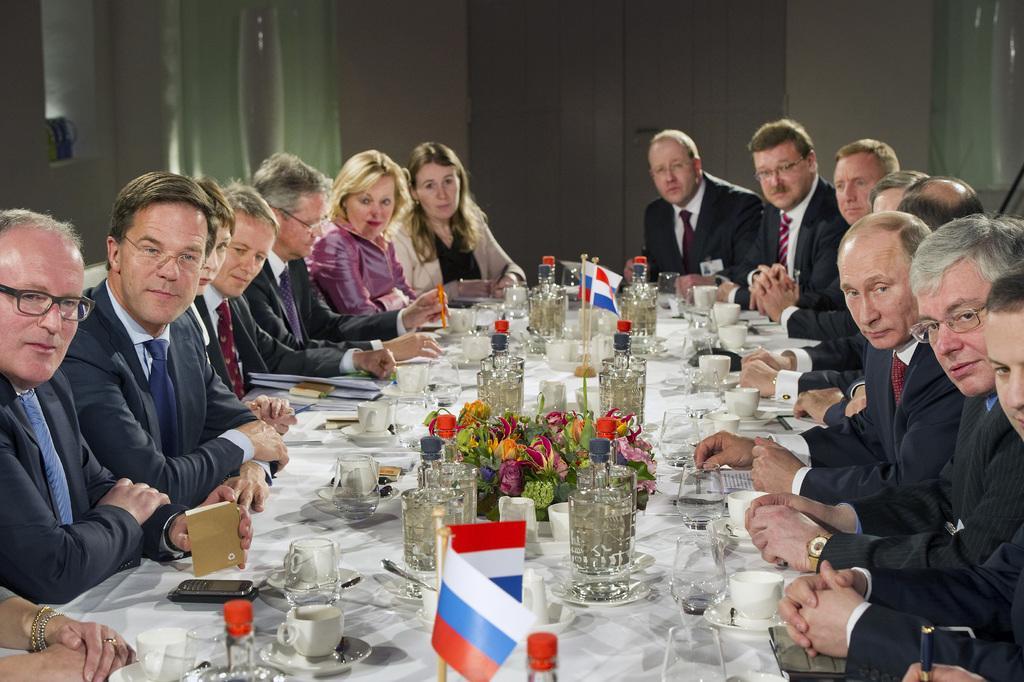Can you describe this image briefly? In this picture, we see many people sitting on either side of the table. In front of them, we see a table on which cup, saucer, water glasses, flower vase, water bottles and mobile phone are placed. Behind them, we see a wall. This picture might be clicked in the conference hall. 